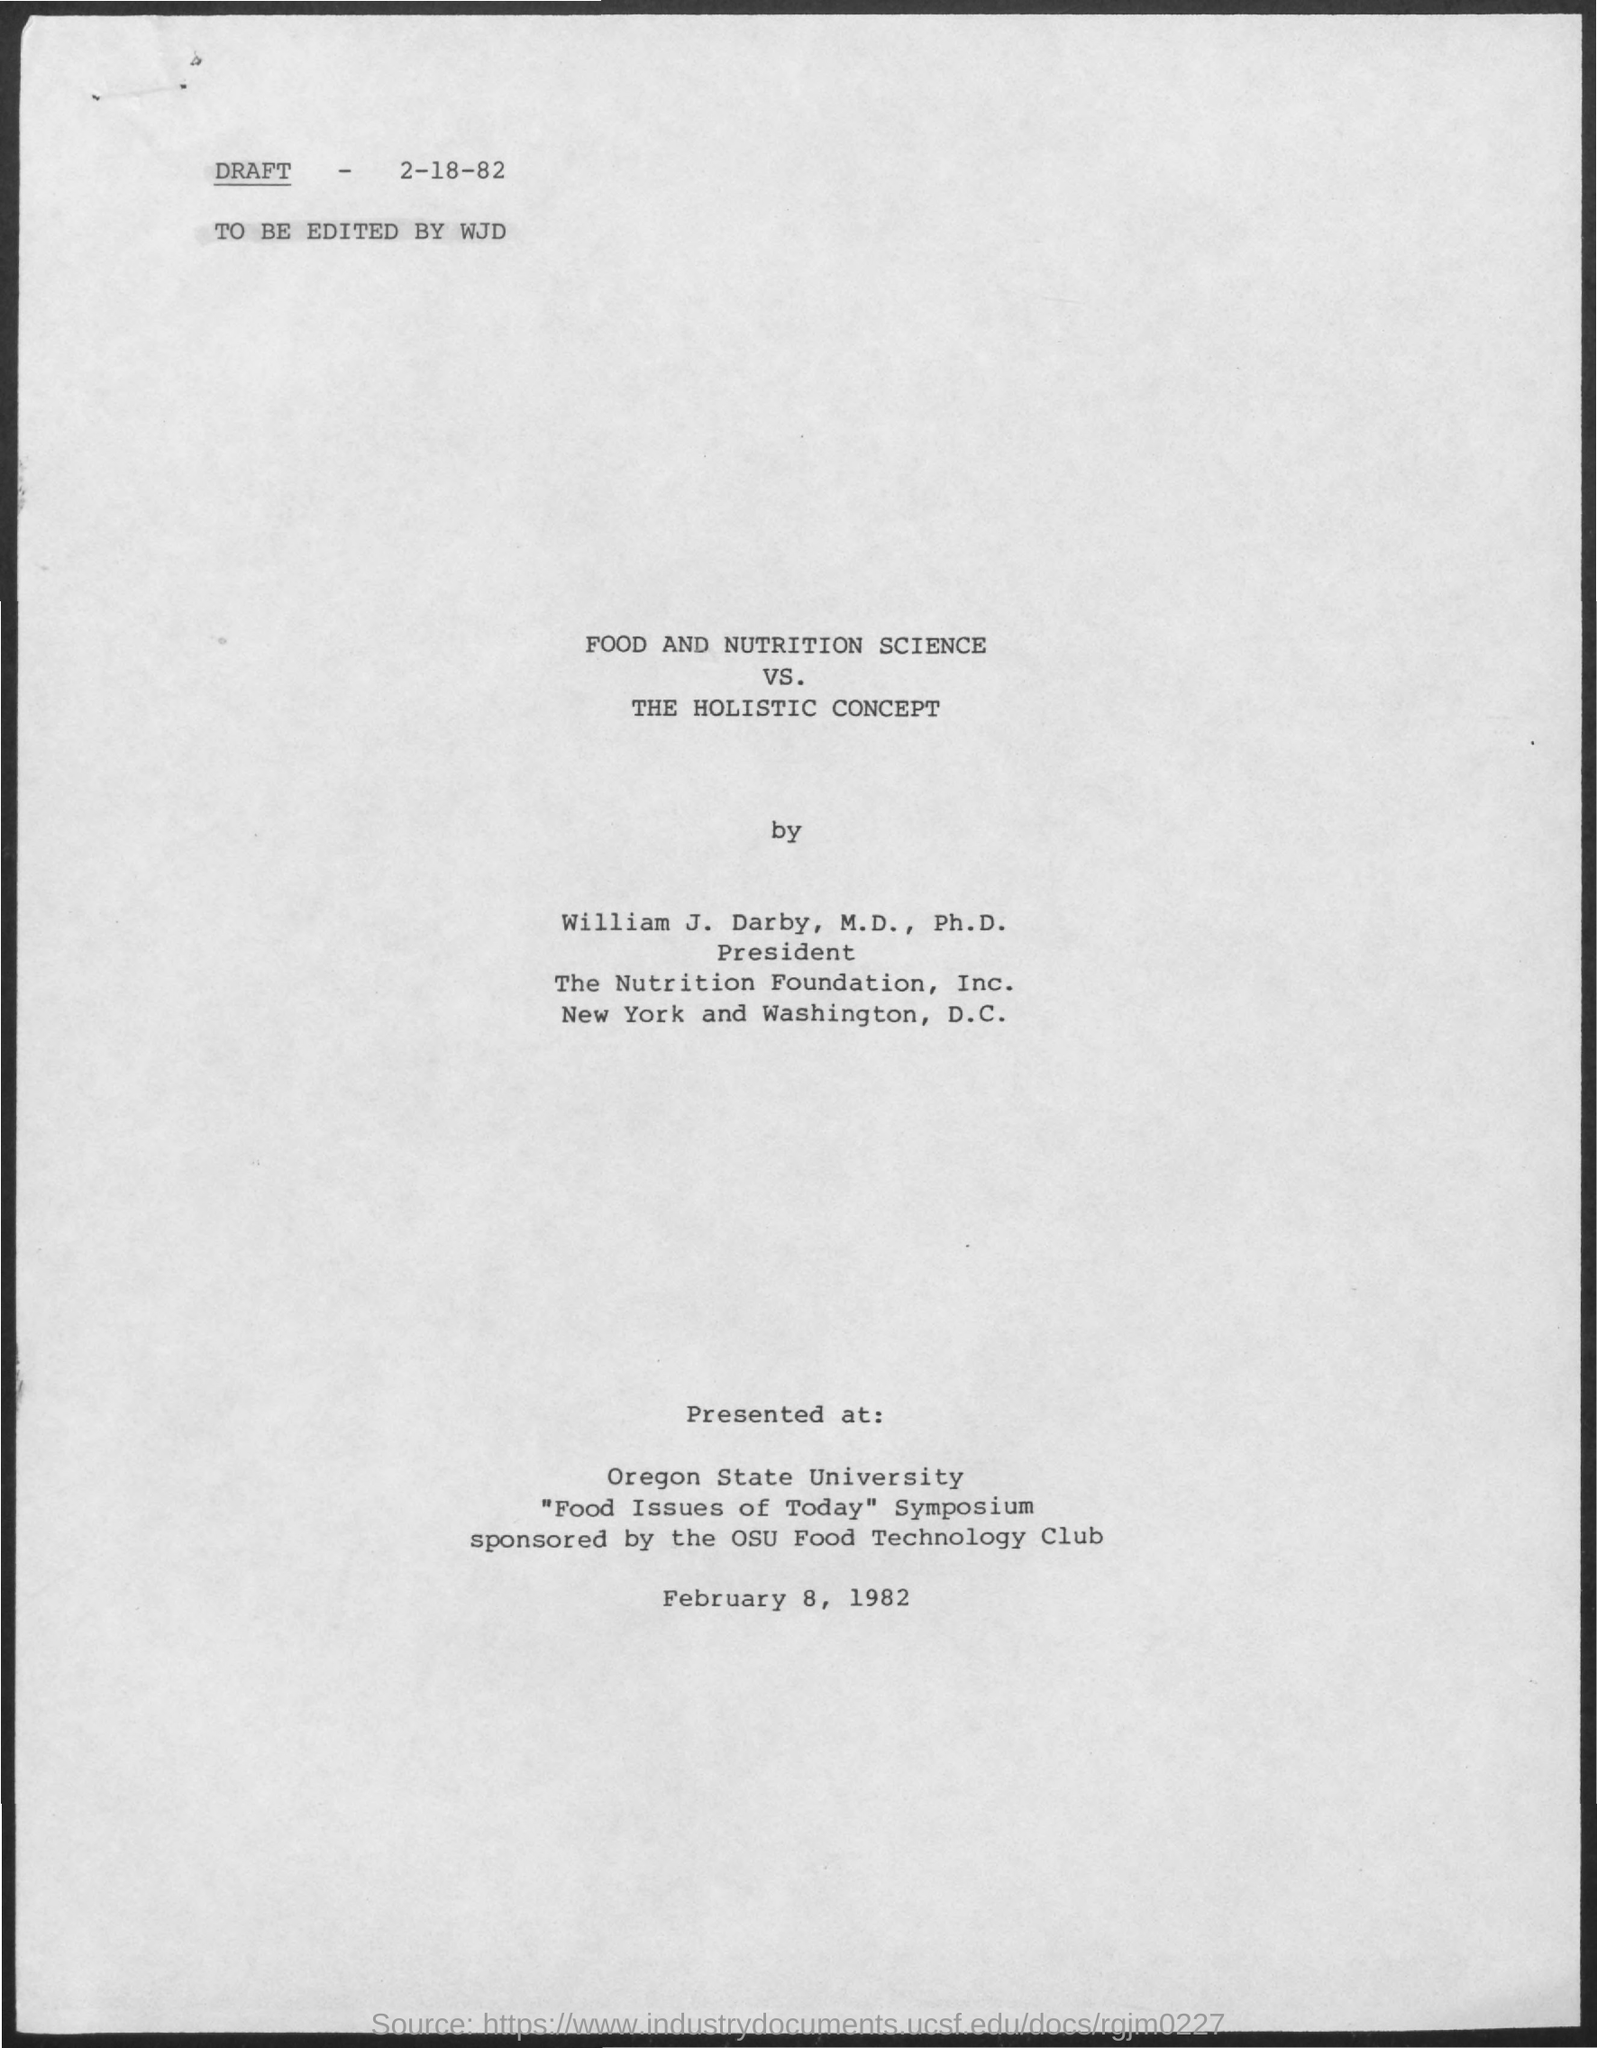Can you tell me what the main topic of this document is? The main topic of the document is 'FOOD AND NUTRITION SCIENCE VS. THE HOLISTIC CONCEPT.' It appears to be a discussion or study related to these subjects. Who is the author and what are his qualifications? The author is William J. Darby, M.D., Ph.D., and he is noted as the President of The Nutrition Foundation, Inc., suggesting a strong professional background in nutrition science. 